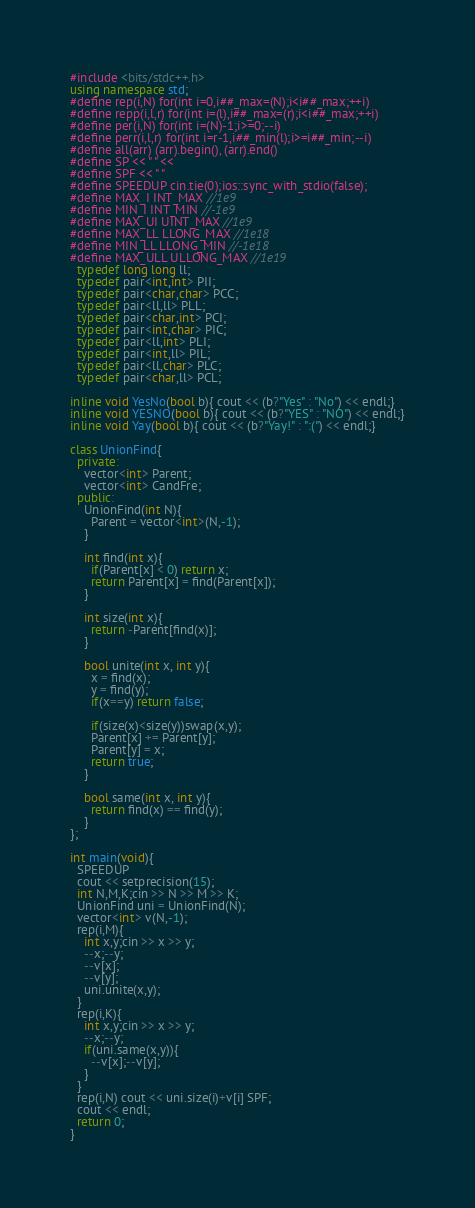<code> <loc_0><loc_0><loc_500><loc_500><_C++_>#include <bits/stdc++.h>
using namespace std;
#define rep(i,N) for(int i=0,i##_max=(N);i<i##_max;++i)
#define repp(i,l,r) for(int i=(l),i##_max=(r);i<i##_max;++i)
#define per(i,N) for(int i=(N)-1;i>=0;--i)
#define perr(i,l,r) for(int i=r-1,i##_min(l);i>=i##_min;--i)
#define all(arr) (arr).begin(), (arr).end()
#define SP << " " <<
#define SPF << " "
#define SPEEDUP cin.tie(0);ios::sync_with_stdio(false);
#define MAX_I INT_MAX //1e9
#define MIN_I INT_MIN //-1e9
#define MAX_UI UINT_MAX //1e9
#define MAX_LL LLONG_MAX //1e18
#define MIN_LL LLONG_MIN //-1e18
#define MAX_ULL ULLONG_MAX //1e19
  typedef long long ll;
  typedef pair<int,int> PII;
  typedef pair<char,char> PCC;
  typedef pair<ll,ll> PLL;
  typedef pair<char,int> PCI;
  typedef pair<int,char> PIC;
  typedef pair<ll,int> PLI;
  typedef pair<int,ll> PIL; 
  typedef pair<ll,char> PLC; 
  typedef pair<char,ll> PCL; 

inline void YesNo(bool b){ cout << (b?"Yes" : "No") << endl;}
inline void YESNO(bool b){ cout << (b?"YES" : "NO") << endl;}
inline void Yay(bool b){ cout << (b?"Yay!" : ":(") << endl;}

class UnionFind{
  private:
    vector<int> Parent;
    vector<int> CandFre;
  public:
    UnionFind(int N){
      Parent = vector<int>(N,-1);
    }

    int find(int x){
      if(Parent[x] < 0) return x;
      return Parent[x] = find(Parent[x]);
    }

    int size(int x){
      return -Parent[find(x)];
    }

    bool unite(int x, int y){
      x = find(x);
      y = find(y);
      if(x==y) return false;

      if(size(x)<size(y))swap(x,y);
      Parent[x] += Parent[y];
      Parent[y] = x;
      return true;
    }

    bool same(int x, int y){
      return find(x) == find(y);
    }
};

int main(void){
  SPEEDUP
  cout << setprecision(15);
  int N,M,K;cin >> N >> M >> K;
  UnionFind uni = UnionFind(N);
  vector<int> v(N,-1);
  rep(i,M){
    int x,y;cin >> x >> y;
    --x;--y;
    --v[x];
    --v[y];
    uni.unite(x,y);
  }
  rep(i,K){
    int x,y;cin >> x >> y;
    --x;--y;
    if(uni.same(x,y)){
      --v[x];--v[y];
    }
  }
  rep(i,N) cout << uni.size(i)+v[i] SPF;
  cout << endl;
  return 0;
}
</code> 